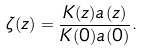<formula> <loc_0><loc_0><loc_500><loc_500>\zeta ( z ) = \frac { K ( z ) a ( z ) } { K ( 0 ) a ( 0 ) } .</formula> 